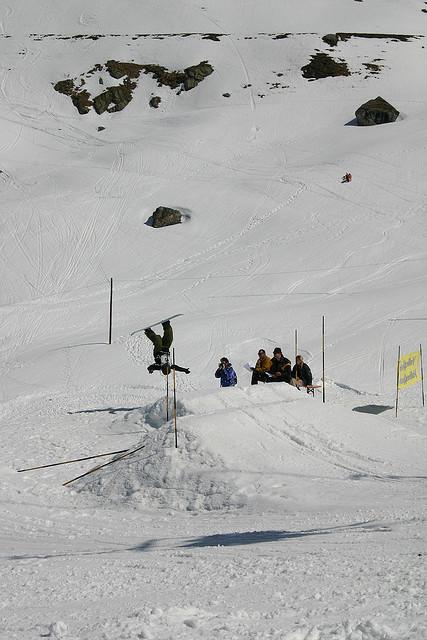Is someone doing a trick?
Be succinct. Yes. How many spectators are there?
Be succinct. 4. Are there any trees visible in this picture?
Write a very short answer. No. Has anyone else been skiing?
Keep it brief. Yes. Are there any trees?
Be succinct. No. Is this an adult?
Concise answer only. Yes. Are the people in the mountains?
Keep it brief. Yes. Is it snowing outside?
Be succinct. No. 